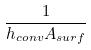<formula> <loc_0><loc_0><loc_500><loc_500>\frac { 1 } { h _ { c o n v } A _ { s u r f } }</formula> 